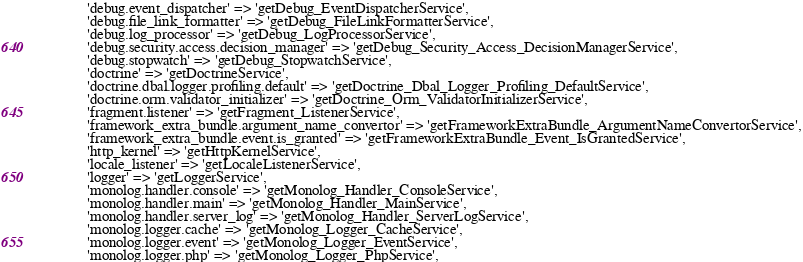<code> <loc_0><loc_0><loc_500><loc_500><_PHP_>            'debug.event_dispatcher' => 'getDebug_EventDispatcherService',
            'debug.file_link_formatter' => 'getDebug_FileLinkFormatterService',
            'debug.log_processor' => 'getDebug_LogProcessorService',
            'debug.security.access.decision_manager' => 'getDebug_Security_Access_DecisionManagerService',
            'debug.stopwatch' => 'getDebug_StopwatchService',
            'doctrine' => 'getDoctrineService',
            'doctrine.dbal.logger.profiling.default' => 'getDoctrine_Dbal_Logger_Profiling_DefaultService',
            'doctrine.orm.validator_initializer' => 'getDoctrine_Orm_ValidatorInitializerService',
            'fragment.listener' => 'getFragment_ListenerService',
            'framework_extra_bundle.argument_name_convertor' => 'getFrameworkExtraBundle_ArgumentNameConvertorService',
            'framework_extra_bundle.event.is_granted' => 'getFrameworkExtraBundle_Event_IsGrantedService',
            'http_kernel' => 'getHttpKernelService',
            'locale_listener' => 'getLocaleListenerService',
            'logger' => 'getLoggerService',
            'monolog.handler.console' => 'getMonolog_Handler_ConsoleService',
            'monolog.handler.main' => 'getMonolog_Handler_MainService',
            'monolog.handler.server_log' => 'getMonolog_Handler_ServerLogService',
            'monolog.logger.cache' => 'getMonolog_Logger_CacheService',
            'monolog.logger.event' => 'getMonolog_Logger_EventService',
            'monolog.logger.php' => 'getMonolog_Logger_PhpService',</code> 